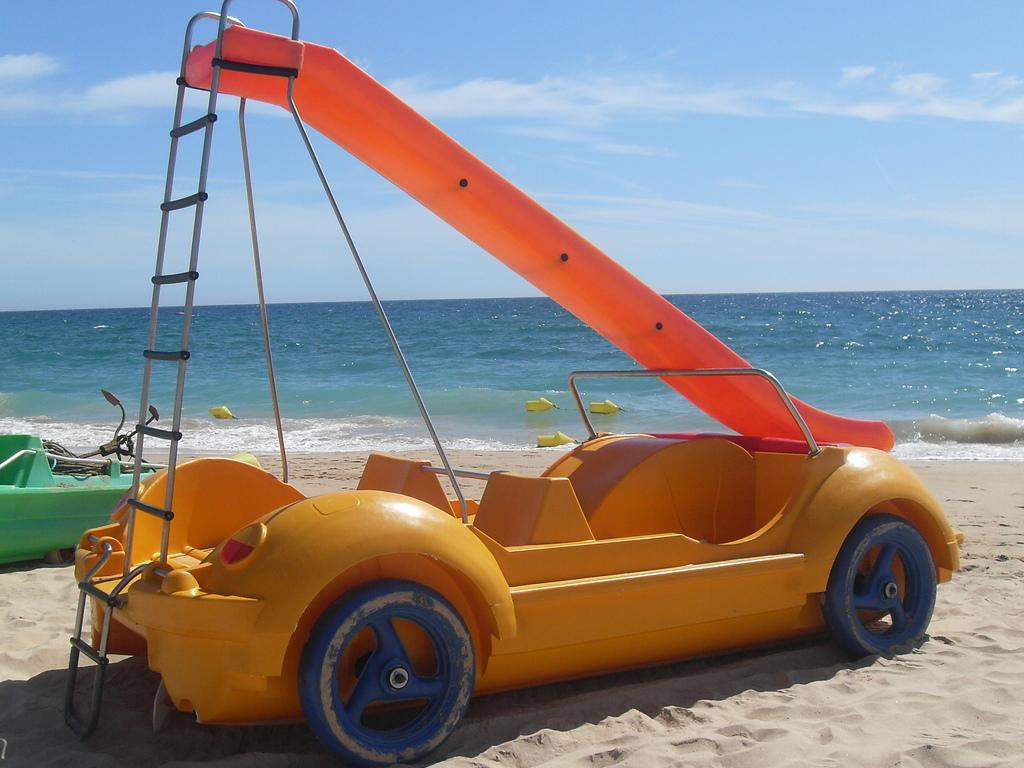What can be seen in the foreground of the image? There are two vehicles in the foreground of the image. Where are the vehicles located? on the beach? What is visible in the water in the background of the image? There are objects visible in the water in the background of the image. What can be seen in the sky in the background of the image? The sky is visible in the background of the image. What type of rock is being observed by the vehicles in the image? There is no rock being observed by the vehicles in the image; they are simply located on a beach. 